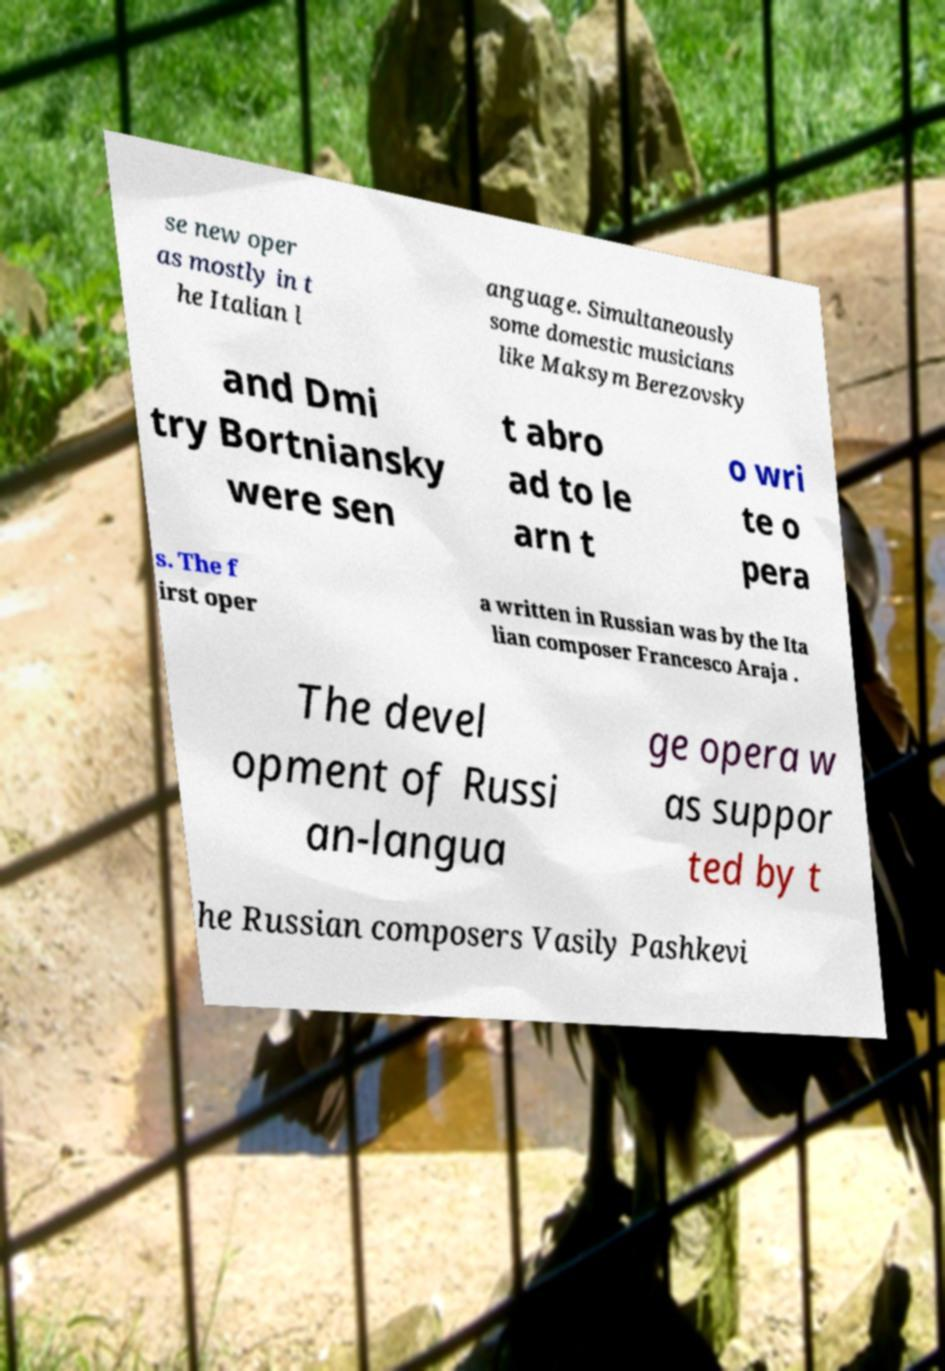What messages or text are displayed in this image? I need them in a readable, typed format. se new oper as mostly in t he Italian l anguage. Simultaneously some domestic musicians like Maksym Berezovsky and Dmi try Bortniansky were sen t abro ad to le arn t o wri te o pera s. The f irst oper a written in Russian was by the Ita lian composer Francesco Araja . The devel opment of Russi an-langua ge opera w as suppor ted by t he Russian composers Vasily Pashkevi 